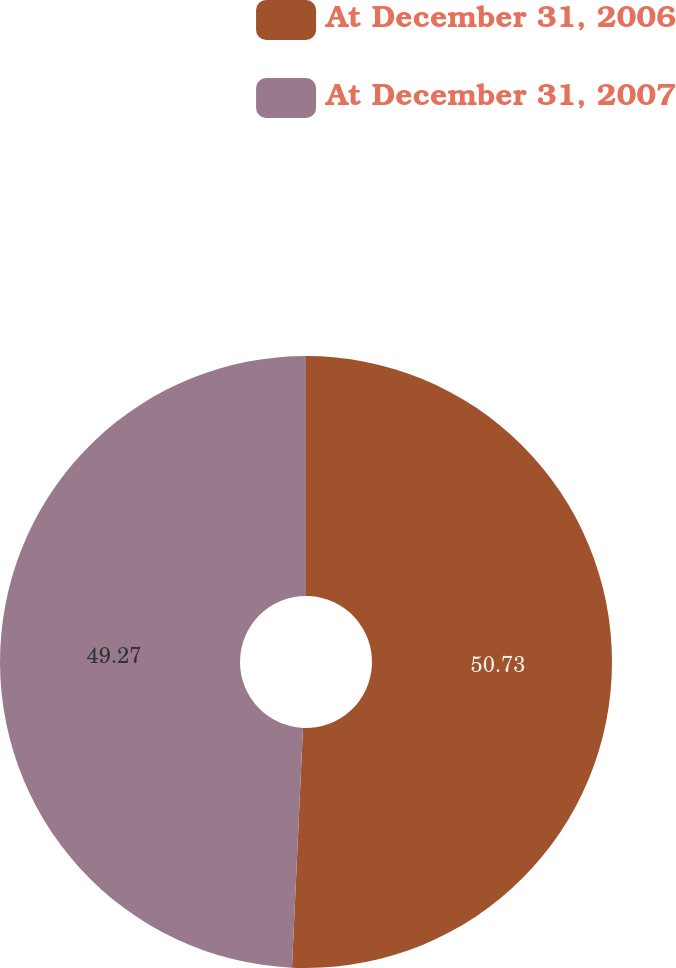Convert chart. <chart><loc_0><loc_0><loc_500><loc_500><pie_chart><fcel>At December 31, 2006<fcel>At December 31, 2007<nl><fcel>50.73%<fcel>49.27%<nl></chart> 